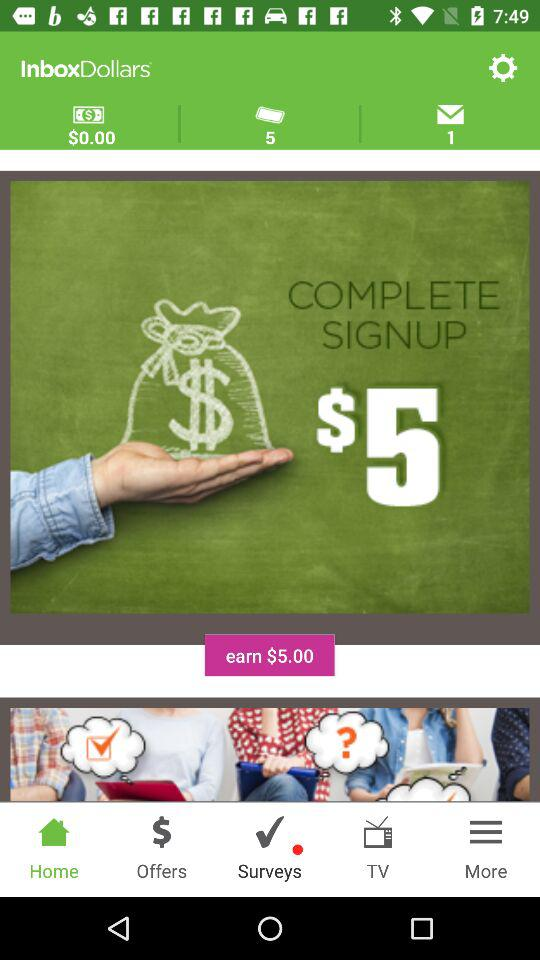How many messages are in my inbox? There is 1 message in your inbox. 